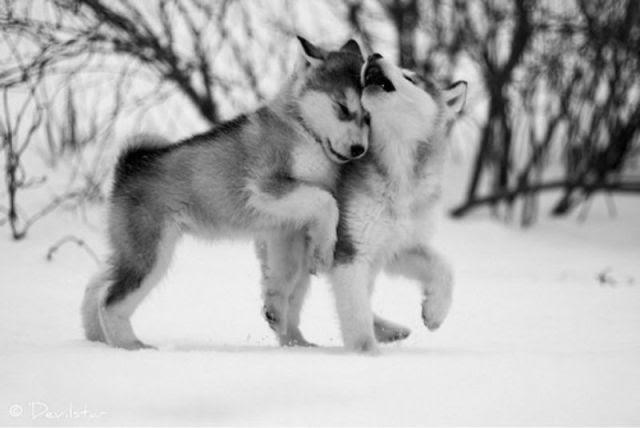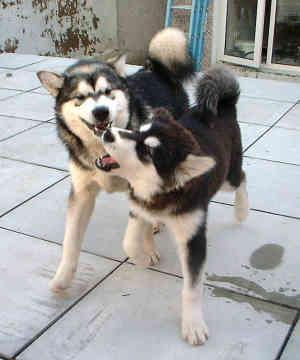The first image is the image on the left, the second image is the image on the right. Assess this claim about the two images: "Each image contains two husky dogs positioned close together, and one image features dogs standing on snow-covered ground.". Correct or not? Answer yes or no. Yes. The first image is the image on the left, the second image is the image on the right. Evaluate the accuracy of this statement regarding the images: "The left image contains exactly two dogs.". Is it true? Answer yes or no. Yes. 